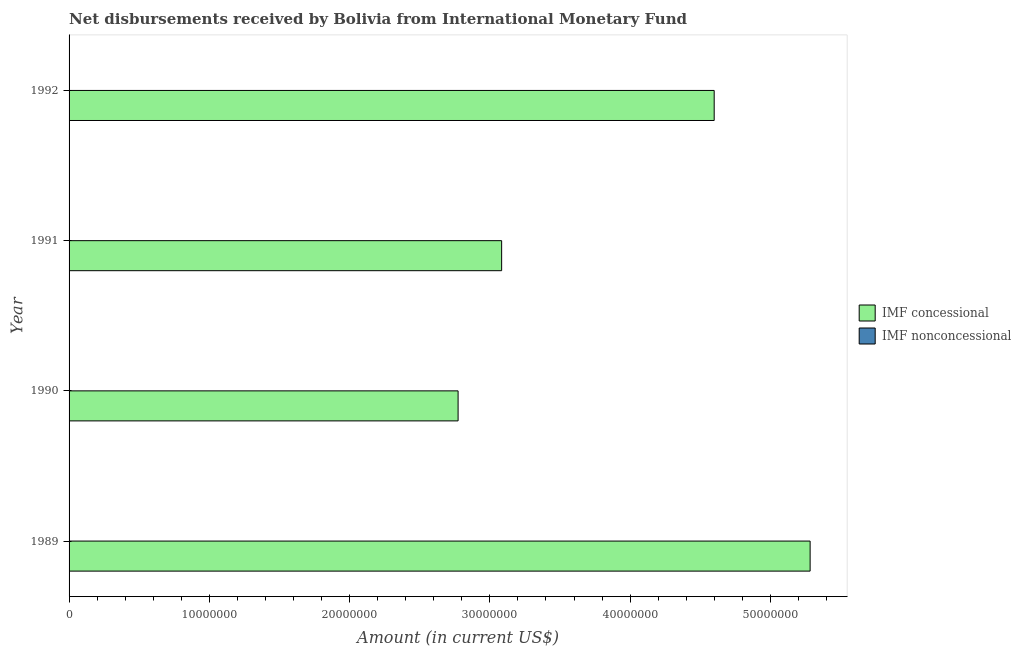Are the number of bars per tick equal to the number of legend labels?
Your answer should be very brief. No. Are the number of bars on each tick of the Y-axis equal?
Your response must be concise. Yes. How many bars are there on the 3rd tick from the bottom?
Give a very brief answer. 1. What is the label of the 2nd group of bars from the top?
Your response must be concise. 1991. In how many cases, is the number of bars for a given year not equal to the number of legend labels?
Provide a succinct answer. 4. Across all years, what is the maximum net concessional disbursements from imf?
Make the answer very short. 5.28e+07. Across all years, what is the minimum net concessional disbursements from imf?
Keep it short and to the point. 2.77e+07. What is the total net concessional disbursements from imf in the graph?
Your response must be concise. 1.57e+08. What is the difference between the net concessional disbursements from imf in 1991 and that in 1992?
Make the answer very short. -1.52e+07. What is the difference between the net concessional disbursements from imf in 1992 and the net non concessional disbursements from imf in 1990?
Provide a succinct answer. 4.60e+07. What is the average net non concessional disbursements from imf per year?
Your response must be concise. 0. What is the ratio of the net concessional disbursements from imf in 1991 to that in 1992?
Give a very brief answer. 0.67. Is the net concessional disbursements from imf in 1990 less than that in 1992?
Your answer should be compact. Yes. What is the difference between the highest and the second highest net concessional disbursements from imf?
Keep it short and to the point. 6.84e+06. Are the values on the major ticks of X-axis written in scientific E-notation?
Ensure brevity in your answer.  No. Does the graph contain any zero values?
Provide a short and direct response. Yes. Where does the legend appear in the graph?
Your answer should be very brief. Center right. What is the title of the graph?
Make the answer very short. Net disbursements received by Bolivia from International Monetary Fund. What is the Amount (in current US$) in IMF concessional in 1989?
Ensure brevity in your answer.  5.28e+07. What is the Amount (in current US$) of IMF concessional in 1990?
Give a very brief answer. 2.77e+07. What is the Amount (in current US$) of IMF concessional in 1991?
Make the answer very short. 3.08e+07. What is the Amount (in current US$) of IMF concessional in 1992?
Give a very brief answer. 4.60e+07. Across all years, what is the maximum Amount (in current US$) of IMF concessional?
Make the answer very short. 5.28e+07. Across all years, what is the minimum Amount (in current US$) of IMF concessional?
Make the answer very short. 2.77e+07. What is the total Amount (in current US$) in IMF concessional in the graph?
Provide a succinct answer. 1.57e+08. What is the difference between the Amount (in current US$) in IMF concessional in 1989 and that in 1990?
Offer a terse response. 2.51e+07. What is the difference between the Amount (in current US$) of IMF concessional in 1989 and that in 1991?
Ensure brevity in your answer.  2.20e+07. What is the difference between the Amount (in current US$) in IMF concessional in 1989 and that in 1992?
Keep it short and to the point. 6.84e+06. What is the difference between the Amount (in current US$) in IMF concessional in 1990 and that in 1991?
Make the answer very short. -3.10e+06. What is the difference between the Amount (in current US$) in IMF concessional in 1990 and that in 1992?
Offer a very short reply. -1.83e+07. What is the difference between the Amount (in current US$) in IMF concessional in 1991 and that in 1992?
Your answer should be very brief. -1.52e+07. What is the average Amount (in current US$) in IMF concessional per year?
Provide a short and direct response. 3.94e+07. What is the ratio of the Amount (in current US$) of IMF concessional in 1989 to that in 1990?
Provide a short and direct response. 1.9. What is the ratio of the Amount (in current US$) in IMF concessional in 1989 to that in 1991?
Give a very brief answer. 1.71. What is the ratio of the Amount (in current US$) of IMF concessional in 1989 to that in 1992?
Provide a short and direct response. 1.15. What is the ratio of the Amount (in current US$) in IMF concessional in 1990 to that in 1991?
Make the answer very short. 0.9. What is the ratio of the Amount (in current US$) in IMF concessional in 1990 to that in 1992?
Ensure brevity in your answer.  0.6. What is the ratio of the Amount (in current US$) of IMF concessional in 1991 to that in 1992?
Offer a terse response. 0.67. What is the difference between the highest and the second highest Amount (in current US$) of IMF concessional?
Ensure brevity in your answer.  6.84e+06. What is the difference between the highest and the lowest Amount (in current US$) of IMF concessional?
Keep it short and to the point. 2.51e+07. 